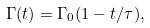Convert formula to latex. <formula><loc_0><loc_0><loc_500><loc_500>\Gamma ( t ) = \Gamma _ { 0 } ( 1 - t / \tau ) ,</formula> 